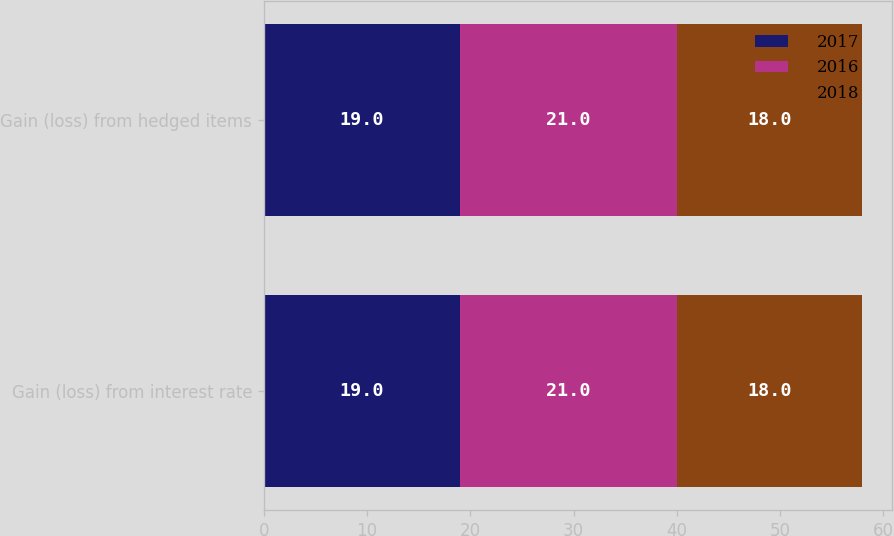<chart> <loc_0><loc_0><loc_500><loc_500><stacked_bar_chart><ecel><fcel>Gain (loss) from interest rate<fcel>Gain (loss) from hedged items<nl><fcel>2017<fcel>19<fcel>19<nl><fcel>2016<fcel>21<fcel>21<nl><fcel>2018<fcel>18<fcel>18<nl></chart> 